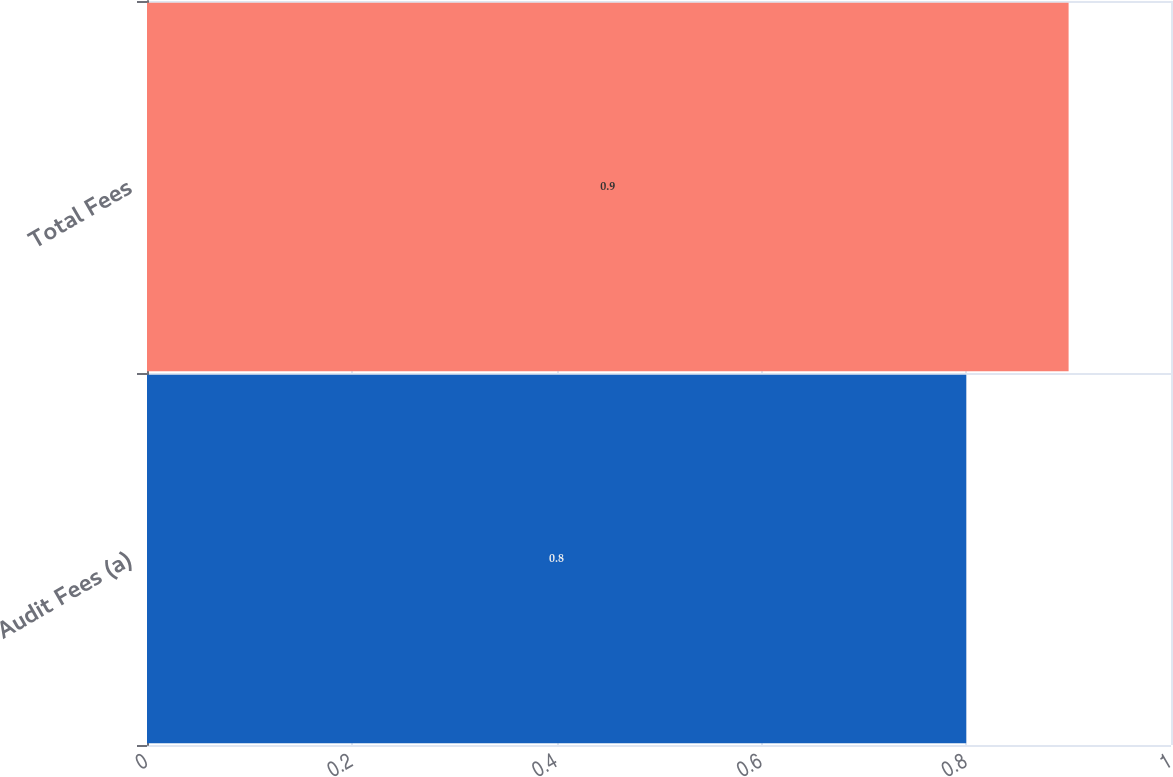Convert chart. <chart><loc_0><loc_0><loc_500><loc_500><bar_chart><fcel>Audit Fees (a)<fcel>Total Fees<nl><fcel>0.8<fcel>0.9<nl></chart> 